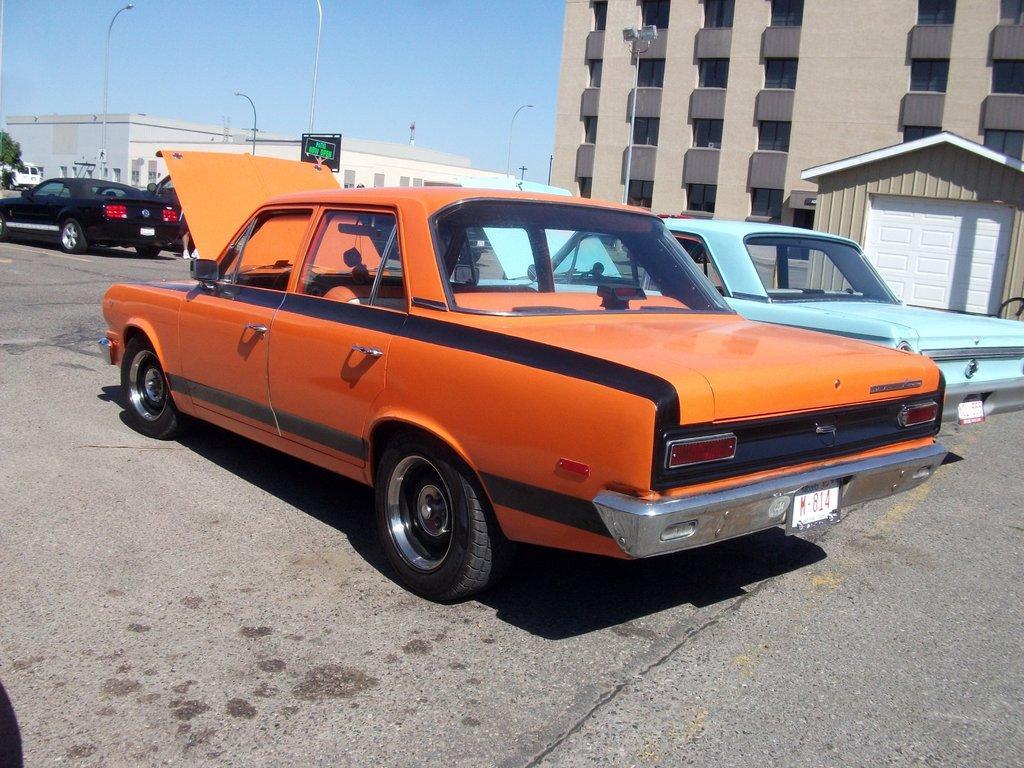Could you give a brief overview of what you see in this image? In this image we can see some cars which are parked on road and in the background of the image there are some buildings, clear sky. 